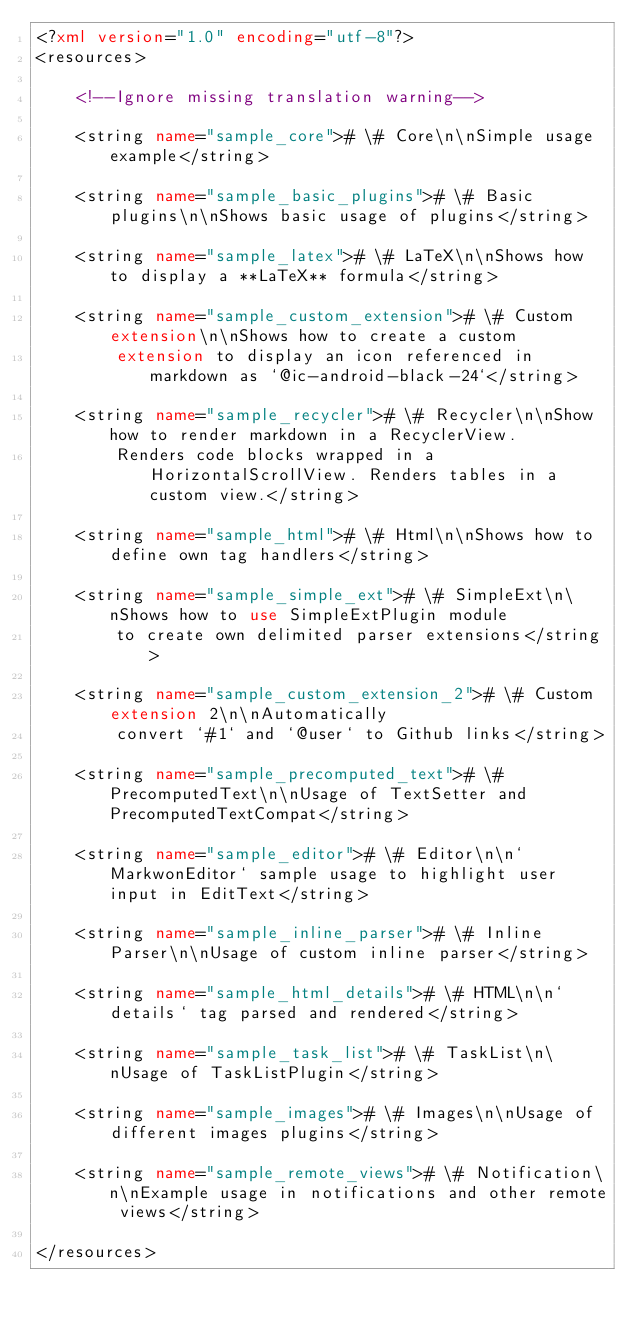Convert code to text. <code><loc_0><loc_0><loc_500><loc_500><_XML_><?xml version="1.0" encoding="utf-8"?>
<resources>

    <!--Ignore missing translation warning-->

    <string name="sample_core"># \# Core\n\nSimple usage example</string>

    <string name="sample_basic_plugins"># \# Basic plugins\n\nShows basic usage of plugins</string>

    <string name="sample_latex"># \# LaTeX\n\nShows how to display a **LaTeX** formula</string>

    <string name="sample_custom_extension"># \# Custom extension\n\nShows how to create a custom
        extension to display an icon referenced in markdown as `@ic-android-black-24`</string>

    <string name="sample_recycler"># \# Recycler\n\nShow how to render markdown in a RecyclerView.
        Renders code blocks wrapped in a HorizontalScrollView. Renders tables in a custom view.</string>

    <string name="sample_html"># \# Html\n\nShows how to define own tag handlers</string>

    <string name="sample_simple_ext"># \# SimpleExt\n\nShows how to use SimpleExtPlugin module
        to create own delimited parser extensions</string>

    <string name="sample_custom_extension_2"># \# Custom extension 2\n\nAutomatically
        convert `#1` and `@user` to Github links</string>

    <string name="sample_precomputed_text"># \# PrecomputedText\n\nUsage of TextSetter and PrecomputedTextCompat</string>

    <string name="sample_editor"># \# Editor\n\n`MarkwonEditor` sample usage to highlight user input in EditText</string>

    <string name="sample_inline_parser"># \# Inline Parser\n\nUsage of custom inline parser</string>

    <string name="sample_html_details"># \# HTML\n\n`details` tag parsed and rendered</string>

    <string name="sample_task_list"># \# TaskList\n\nUsage of TaskListPlugin</string>

    <string name="sample_images"># \# Images\n\nUsage of different images plugins</string>

    <string name="sample_remote_views"># \# Notification\n\nExample usage in notifications and other remote views</string>

</resources></code> 